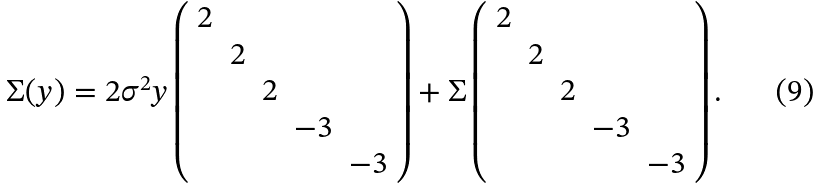<formula> <loc_0><loc_0><loc_500><loc_500>\Sigma ( y ) = 2 \sigma ^ { 2 } y \left ( \begin{array} { c c c c c } 2 & & & & \\ & 2 & & & \\ & & 2 & & \\ & & & - 3 & \\ & & & & - 3 \end{array} \right ) + \Sigma \left ( \begin{array} { c c c c c } 2 & & & & \\ & 2 & & & \\ & & 2 & & \\ & & & - 3 & \\ & & & & - 3 \end{array} \right ) .</formula> 